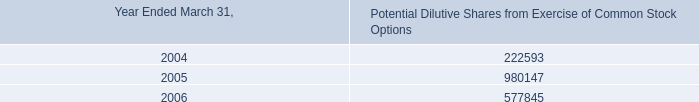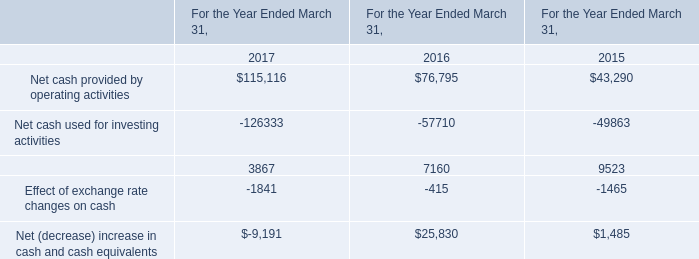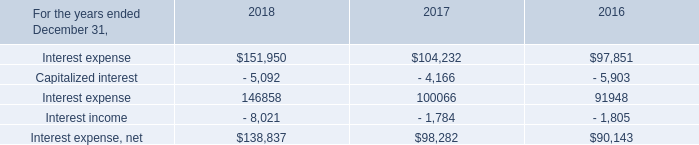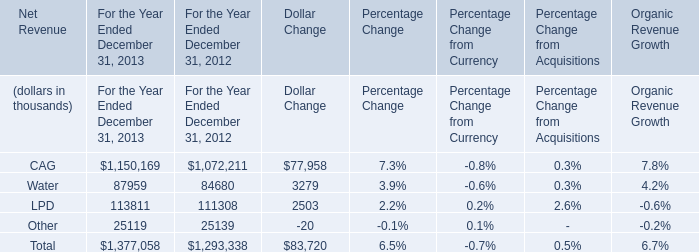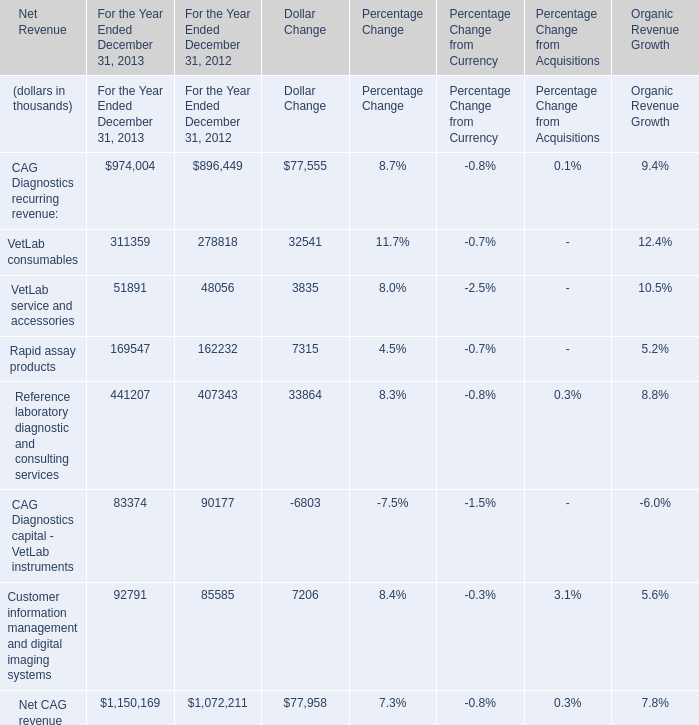at march 31 , 2006 , how much loss could be recognized if they sold the held-to-maturity investment portfolio? 
Computations: (29669000 - 29570000)
Answer: 99000.0. 